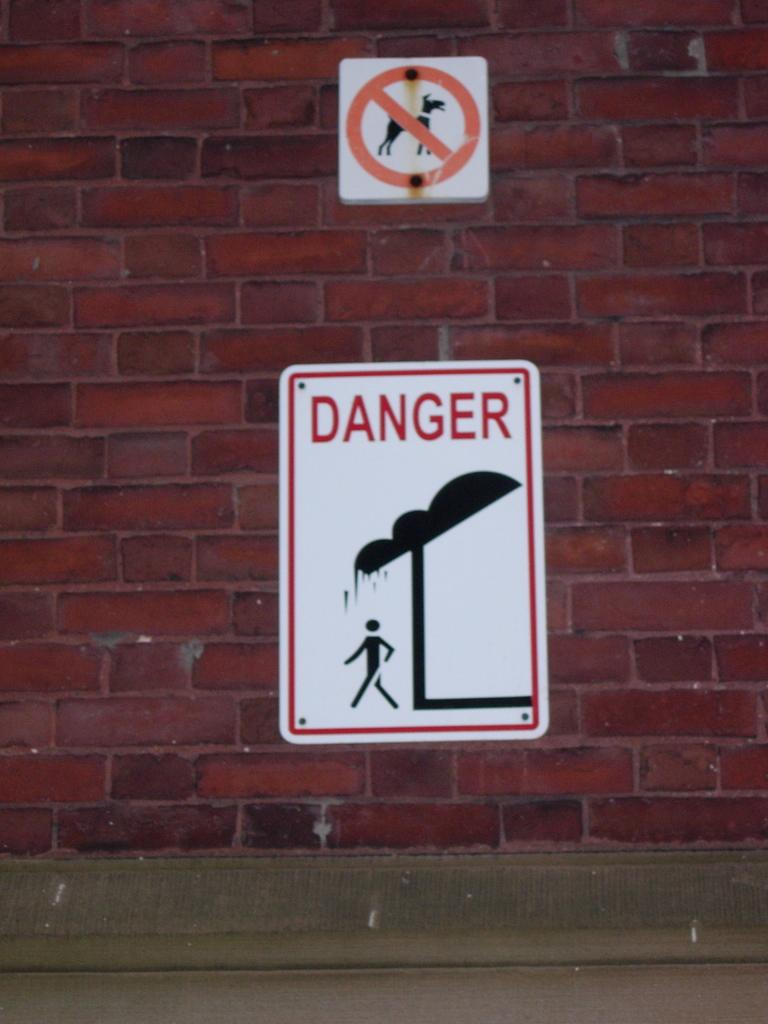<image>
Write a terse but informative summary of the picture. Two street signs, one say no dogs, the other says danger. 